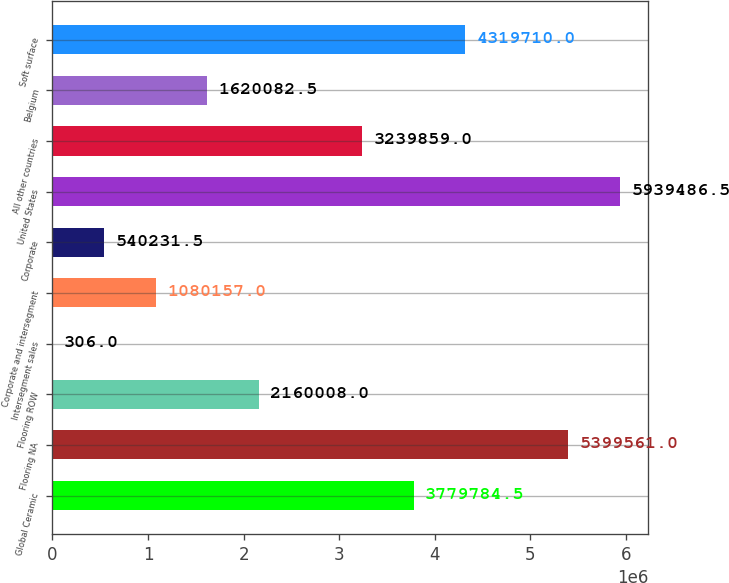Convert chart to OTSL. <chart><loc_0><loc_0><loc_500><loc_500><bar_chart><fcel>Global Ceramic<fcel>Flooring NA<fcel>Flooring ROW<fcel>Intersegment sales<fcel>Corporate and intersegment<fcel>Corporate<fcel>United States<fcel>All other countries<fcel>Belgium<fcel>Soft surface<nl><fcel>3.77978e+06<fcel>5.39956e+06<fcel>2.16001e+06<fcel>306<fcel>1.08016e+06<fcel>540232<fcel>5.93949e+06<fcel>3.23986e+06<fcel>1.62008e+06<fcel>4.31971e+06<nl></chart> 